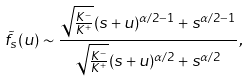<formula> <loc_0><loc_0><loc_500><loc_500>\tilde { f } _ { s } ( u ) \sim \frac { \sqrt { \frac { K ^ { - } } { K ^ { + } } } ( s + u ) ^ { \alpha / 2 - 1 } + s ^ { \alpha / 2 - 1 } } { \sqrt { \frac { K ^ { - } } { K ^ { + } } } ( s + u ) ^ { \alpha / 2 } + s ^ { \alpha / 2 } } ,</formula> 